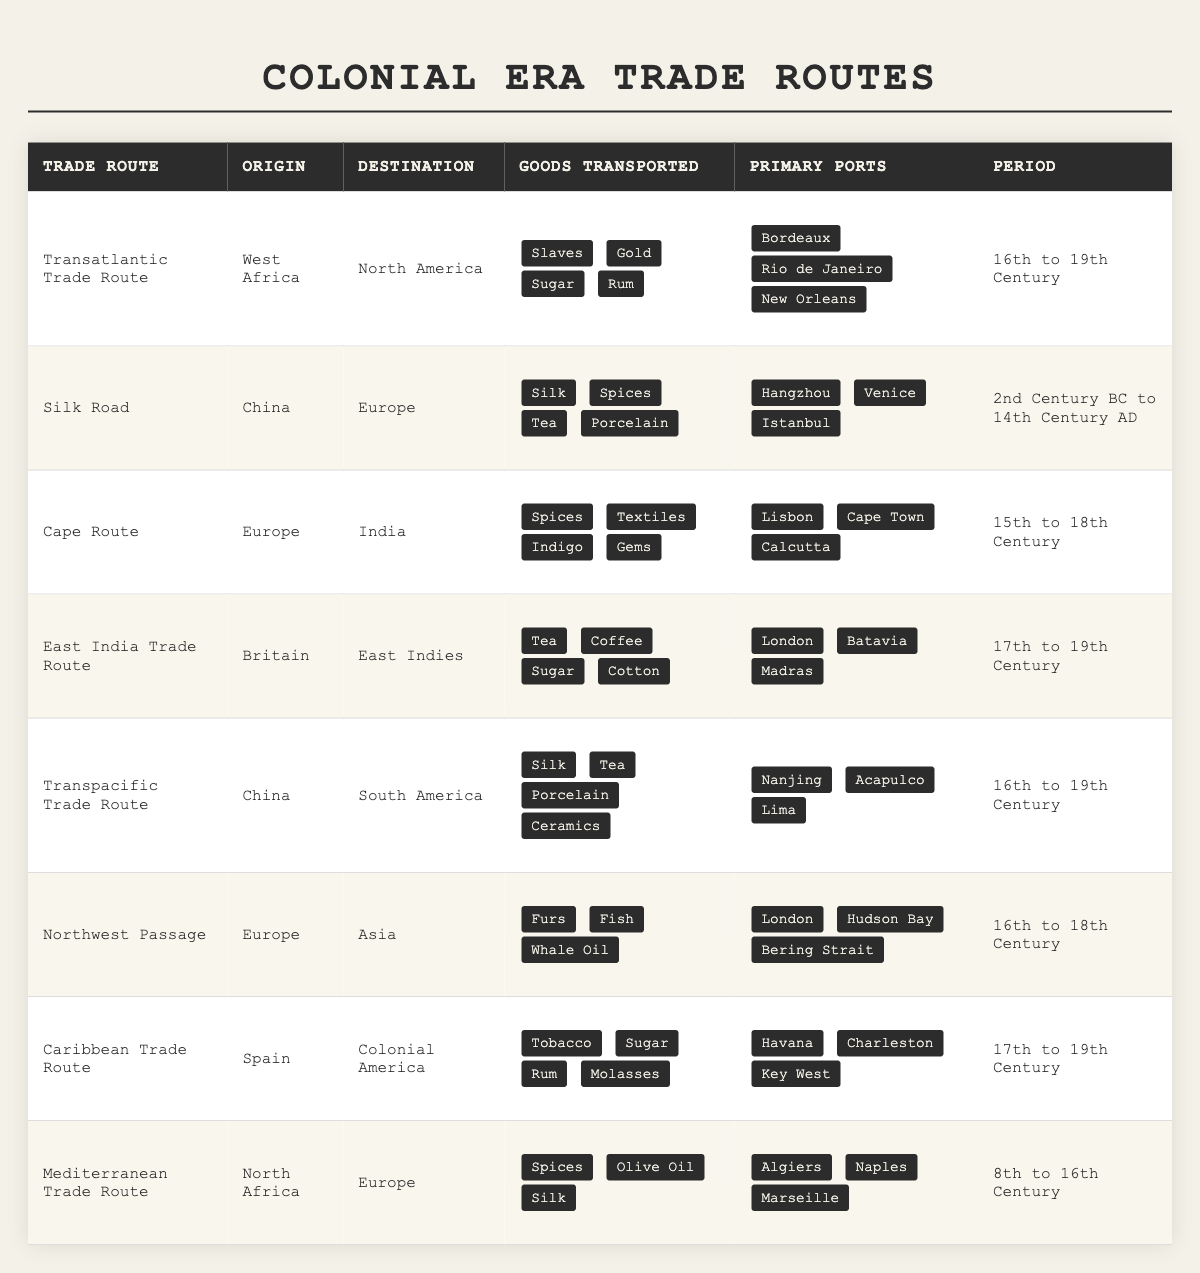What goods were transported via the Caribbean Trade Route? The Caribbean Trade Route transported Tobacco, Sugar, Rum, and Molasses, which can be found in the "Goods Transported" column for that specific route.
Answer: Tobacco, Sugar, Rum, Molasses Which trade route had the longest period of operation? The Silk Road operated from the 2nd Century BC to the 14th Century AD, which is the longest period compared to the other routes listed in the table.
Answer: Silk Road True or False: Spices were transported from China to Europe. According to the table, Spices were listed as goods transported on the Silk Road, which indicates they were exported from China. Thus, the statement is incorrect.
Answer: False How many distinct goods did the Transatlantic Trade Route transport? The Transatlantic Trade Route transported 4 distinct goods: Slaves, Gold, Sugar, and Rum, which can be found in the respective column for that route.
Answer: 4 Which trade route specialized in textiles and indigo? The Cape Route specialized in textiles and indigo, which are listed under the "Goods Transported" for that specific route.
Answer: Cape Route Identify the three primary ports for the East India Trade Route. The primary ports are London, Batavia, and Madras, directly listed in the "Primary Ports" column for the East India Trade Route.
Answer: London, Batavia, Madras Compare the goods transported on the Cape Route and the Caribbean Trade Route. The Cape Route transported Spices, Textiles, Indigo, and Gems, while the Caribbean Trade Route transported Tobacco, Sugar, Rum, and Molasses. Thus, they differ in goods primarily related to spices and textiles versus tobacco and sugar products.
Answer: They differ significantly What was the destination of goods coming from the Northwest Passage? The destination of goods from the Northwest Passage was Asia, as stated in the "Destination" column for that route.
Answer: Asia Determine the total number of trade routes listed that transported sugar. Three trade routes transported sugar: the Transatlantic Trade Route, the East India Trade Route, and the Caribbean Trade Route. Thus, the total is 3 routes.
Answer: 3 Which trade routes shared a common destination of Europe? The Silk Road and the Mediterranean Trade Route both had Europe as their destination, which can be verified in the "Destination" column for those routes.
Answer: Silk Road, Mediterranean Trade Route 